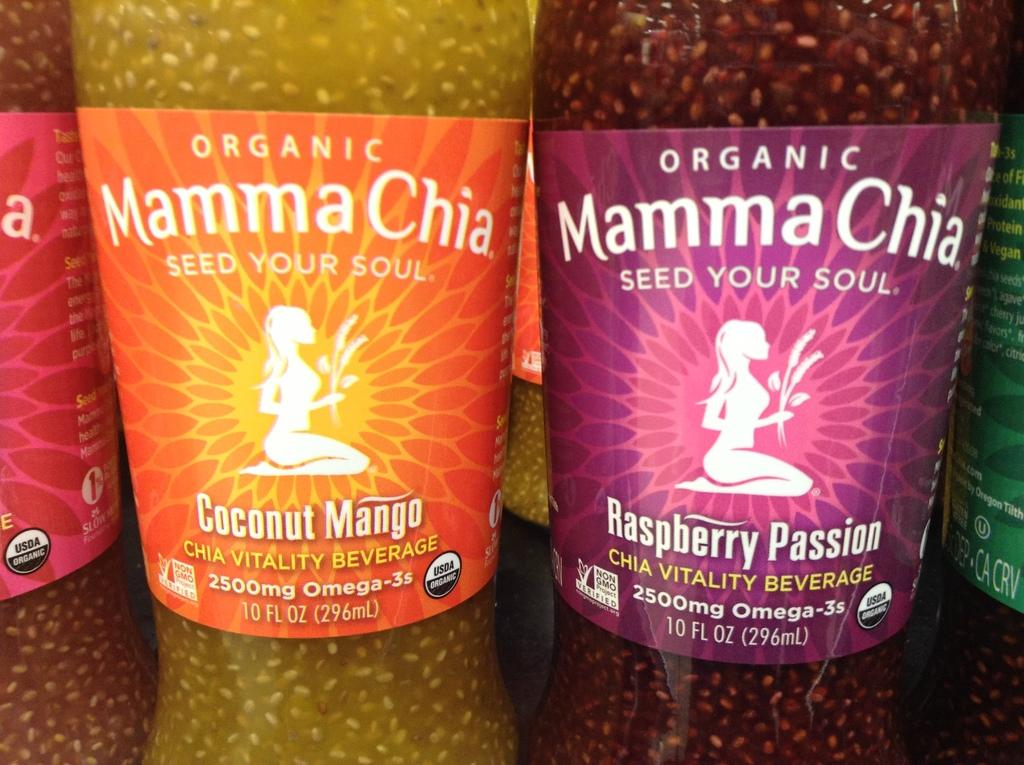What objects can be seen in the image? There are bottles in the image. Can you describe the appearance of the bottles? The bottles are in different colors. Are there any additional elements on the bottles? Yes, there are stickers attached to the bottles. What type of ornament is hanging from the geese in the image? There are no geese or ornaments present in the image; it only features bottles with stickers. 